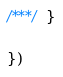Convert code to text. <code><loc_0><loc_0><loc_500><loc_500><_JavaScript_>
/***/ }

})</code> 